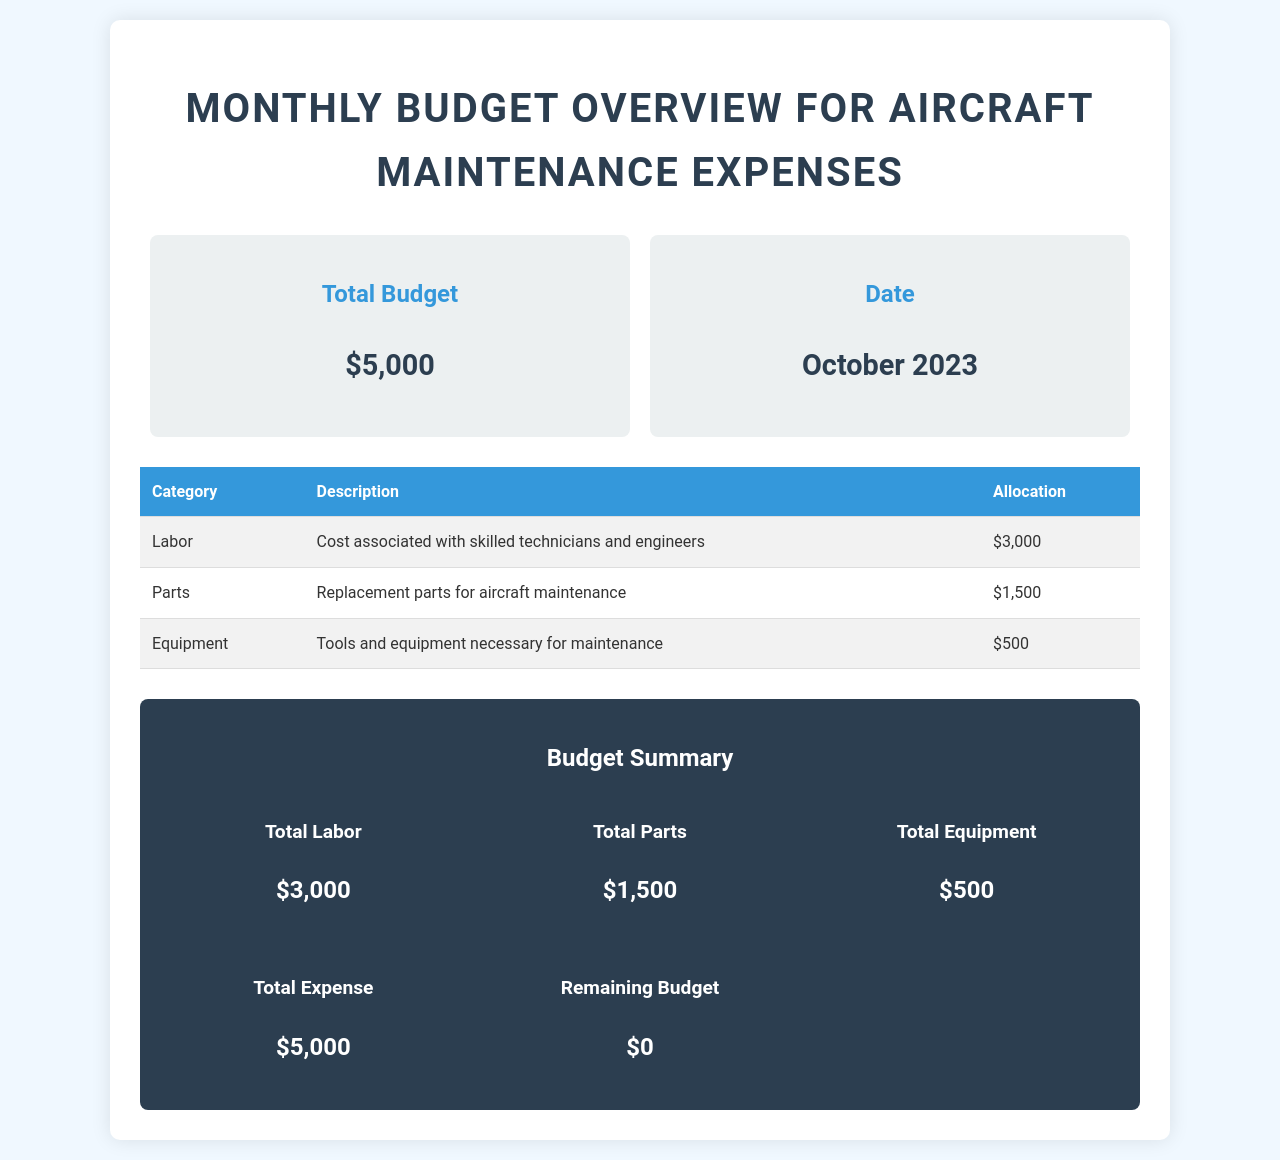What is the total budget? The total budget is clearly stated in the overview section of the document.
Answer: $5,000 When is this budget overview for? The specific date of the budget overview is mentioned in the document.
Answer: October 2023 What is the allocation for labor? The allocation for labor can be found in the table under the Labor category.
Answer: $3,000 How much is allocated for equipment? This amount is specified in the table under the Equipment category.
Answer: $500 What is the total expense? The total expense is summarized in the budget summary section of the document.
Answer: $5,000 What is the remaining budget? This figure is indicated in the budget summary, showing the leftover funds after expenses.
Answer: $0 What category has the highest allocation? The category with the largest amount allocated is stated in the allocation table.
Answer: Labor What description is given for parts? The description provided is found next to the parts allocation entry in the table.
Answer: Replacement parts for aircraft maintenance How many categories are listed in the budget? The number of categories can be counted from the table in the document.
Answer: 3 